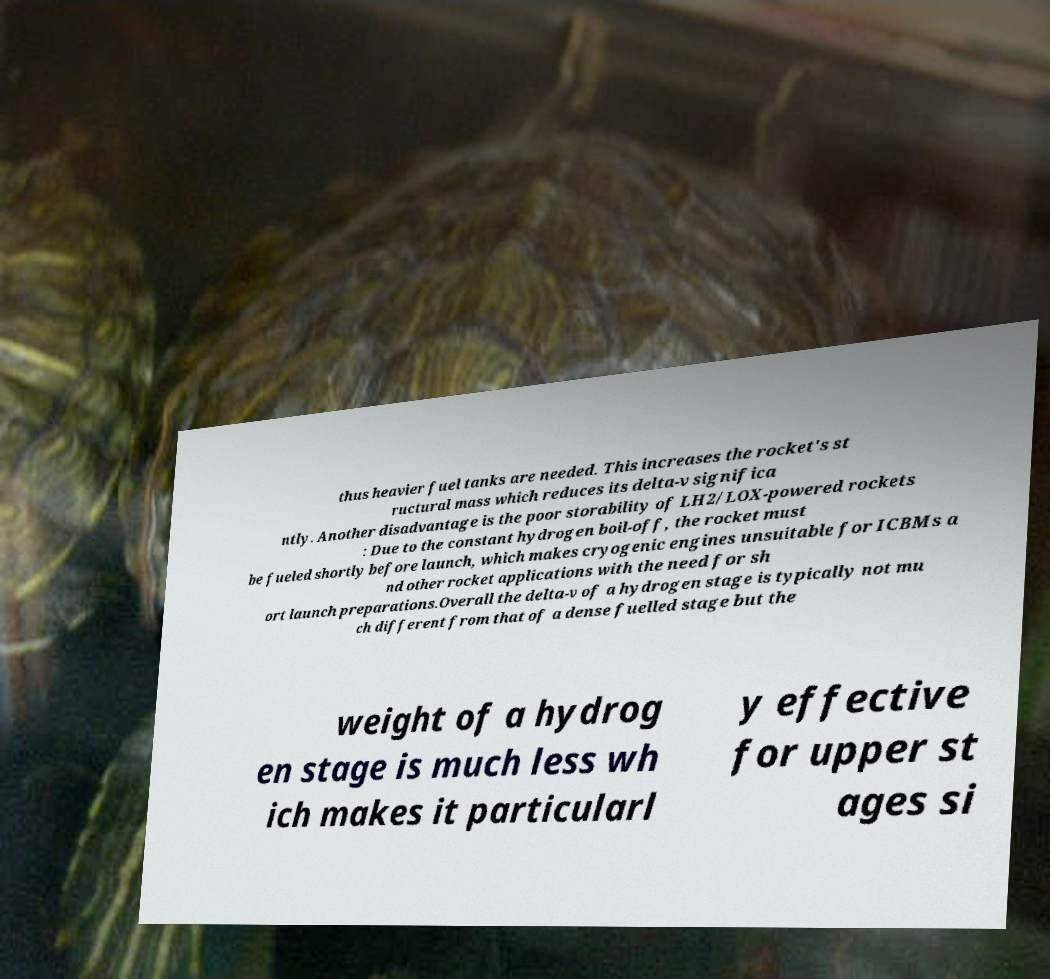I need the written content from this picture converted into text. Can you do that? thus heavier fuel tanks are needed. This increases the rocket's st ructural mass which reduces its delta-v significa ntly. Another disadvantage is the poor storability of LH2/LOX-powered rockets : Due to the constant hydrogen boil-off, the rocket must be fueled shortly before launch, which makes cryogenic engines unsuitable for ICBMs a nd other rocket applications with the need for sh ort launch preparations.Overall the delta-v of a hydrogen stage is typically not mu ch different from that of a dense fuelled stage but the weight of a hydrog en stage is much less wh ich makes it particularl y effective for upper st ages si 